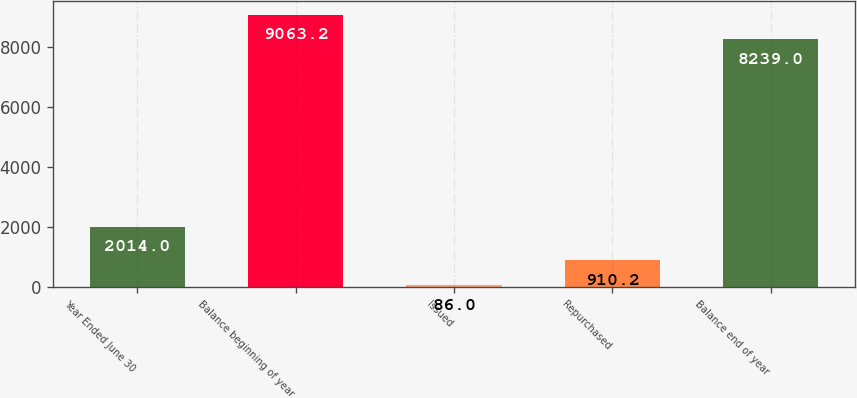<chart> <loc_0><loc_0><loc_500><loc_500><bar_chart><fcel>Year Ended June 30<fcel>Balance beginning of year<fcel>Issued<fcel>Repurchased<fcel>Balance end of year<nl><fcel>2014<fcel>9063.2<fcel>86<fcel>910.2<fcel>8239<nl></chart> 